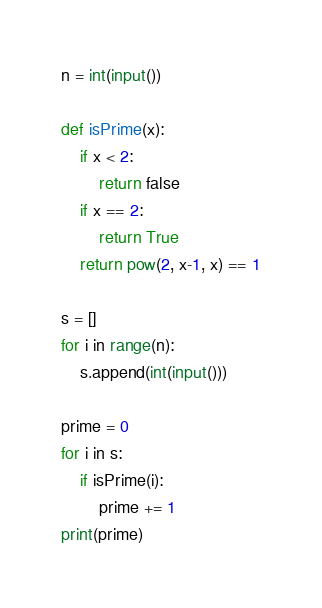<code> <loc_0><loc_0><loc_500><loc_500><_Python_>
n = int(input())

def isPrime(x):
    if x < 2:
        return false
    if x == 2:
        return True
    return pow(2, x-1, x) == 1

s = []
for i in range(n):
    s.append(int(input()))

prime = 0
for i in s:
    if isPrime(i):
        prime += 1
print(prime)</code> 